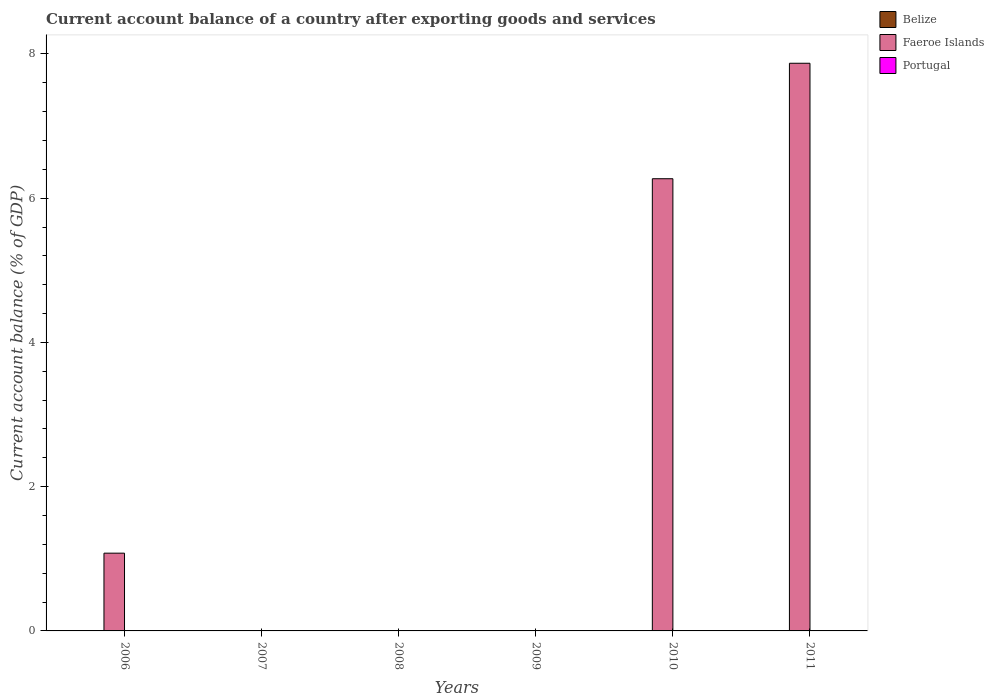How many different coloured bars are there?
Offer a very short reply. 1. Are the number of bars per tick equal to the number of legend labels?
Ensure brevity in your answer.  No. How many bars are there on the 1st tick from the left?
Provide a short and direct response. 1. What is the label of the 5th group of bars from the left?
Your answer should be very brief. 2010. In how many cases, is the number of bars for a given year not equal to the number of legend labels?
Your response must be concise. 6. What is the account balance in Portugal in 2011?
Offer a very short reply. 0. Across all years, what is the maximum account balance in Faeroe Islands?
Give a very brief answer. 7.87. What is the total account balance in Portugal in the graph?
Your answer should be very brief. 0. What is the difference between the highest and the second highest account balance in Faeroe Islands?
Provide a succinct answer. 1.6. What is the difference between the highest and the lowest account balance in Faeroe Islands?
Offer a very short reply. 7.87. Is the sum of the account balance in Faeroe Islands in 2006 and 2010 greater than the maximum account balance in Belize across all years?
Keep it short and to the point. Yes. How many years are there in the graph?
Your answer should be very brief. 6. What is the difference between two consecutive major ticks on the Y-axis?
Provide a short and direct response. 2. How many legend labels are there?
Provide a succinct answer. 3. What is the title of the graph?
Make the answer very short. Current account balance of a country after exporting goods and services. What is the label or title of the Y-axis?
Your answer should be compact. Current account balance (% of GDP). What is the Current account balance (% of GDP) of Faeroe Islands in 2006?
Keep it short and to the point. 1.08. What is the Current account balance (% of GDP) in Portugal in 2006?
Your answer should be compact. 0. What is the Current account balance (% of GDP) in Belize in 2007?
Your response must be concise. 0. What is the Current account balance (% of GDP) of Faeroe Islands in 2007?
Give a very brief answer. 0. What is the Current account balance (% of GDP) in Belize in 2008?
Your response must be concise. 0. What is the Current account balance (% of GDP) of Faeroe Islands in 2009?
Make the answer very short. 0. What is the Current account balance (% of GDP) in Portugal in 2009?
Provide a succinct answer. 0. What is the Current account balance (% of GDP) of Faeroe Islands in 2010?
Provide a short and direct response. 6.27. What is the Current account balance (% of GDP) of Faeroe Islands in 2011?
Your answer should be very brief. 7.87. What is the Current account balance (% of GDP) in Portugal in 2011?
Make the answer very short. 0. Across all years, what is the maximum Current account balance (% of GDP) of Faeroe Islands?
Keep it short and to the point. 7.87. Across all years, what is the minimum Current account balance (% of GDP) in Faeroe Islands?
Provide a short and direct response. 0. What is the total Current account balance (% of GDP) of Faeroe Islands in the graph?
Provide a short and direct response. 15.22. What is the difference between the Current account balance (% of GDP) in Faeroe Islands in 2006 and that in 2010?
Provide a short and direct response. -5.19. What is the difference between the Current account balance (% of GDP) of Faeroe Islands in 2006 and that in 2011?
Keep it short and to the point. -6.79. What is the difference between the Current account balance (% of GDP) in Faeroe Islands in 2010 and that in 2011?
Keep it short and to the point. -1.6. What is the average Current account balance (% of GDP) of Faeroe Islands per year?
Offer a very short reply. 2.54. What is the ratio of the Current account balance (% of GDP) in Faeroe Islands in 2006 to that in 2010?
Provide a short and direct response. 0.17. What is the ratio of the Current account balance (% of GDP) of Faeroe Islands in 2006 to that in 2011?
Your answer should be very brief. 0.14. What is the ratio of the Current account balance (% of GDP) of Faeroe Islands in 2010 to that in 2011?
Give a very brief answer. 0.8. What is the difference between the highest and the second highest Current account balance (% of GDP) in Faeroe Islands?
Your response must be concise. 1.6. What is the difference between the highest and the lowest Current account balance (% of GDP) in Faeroe Islands?
Keep it short and to the point. 7.87. 